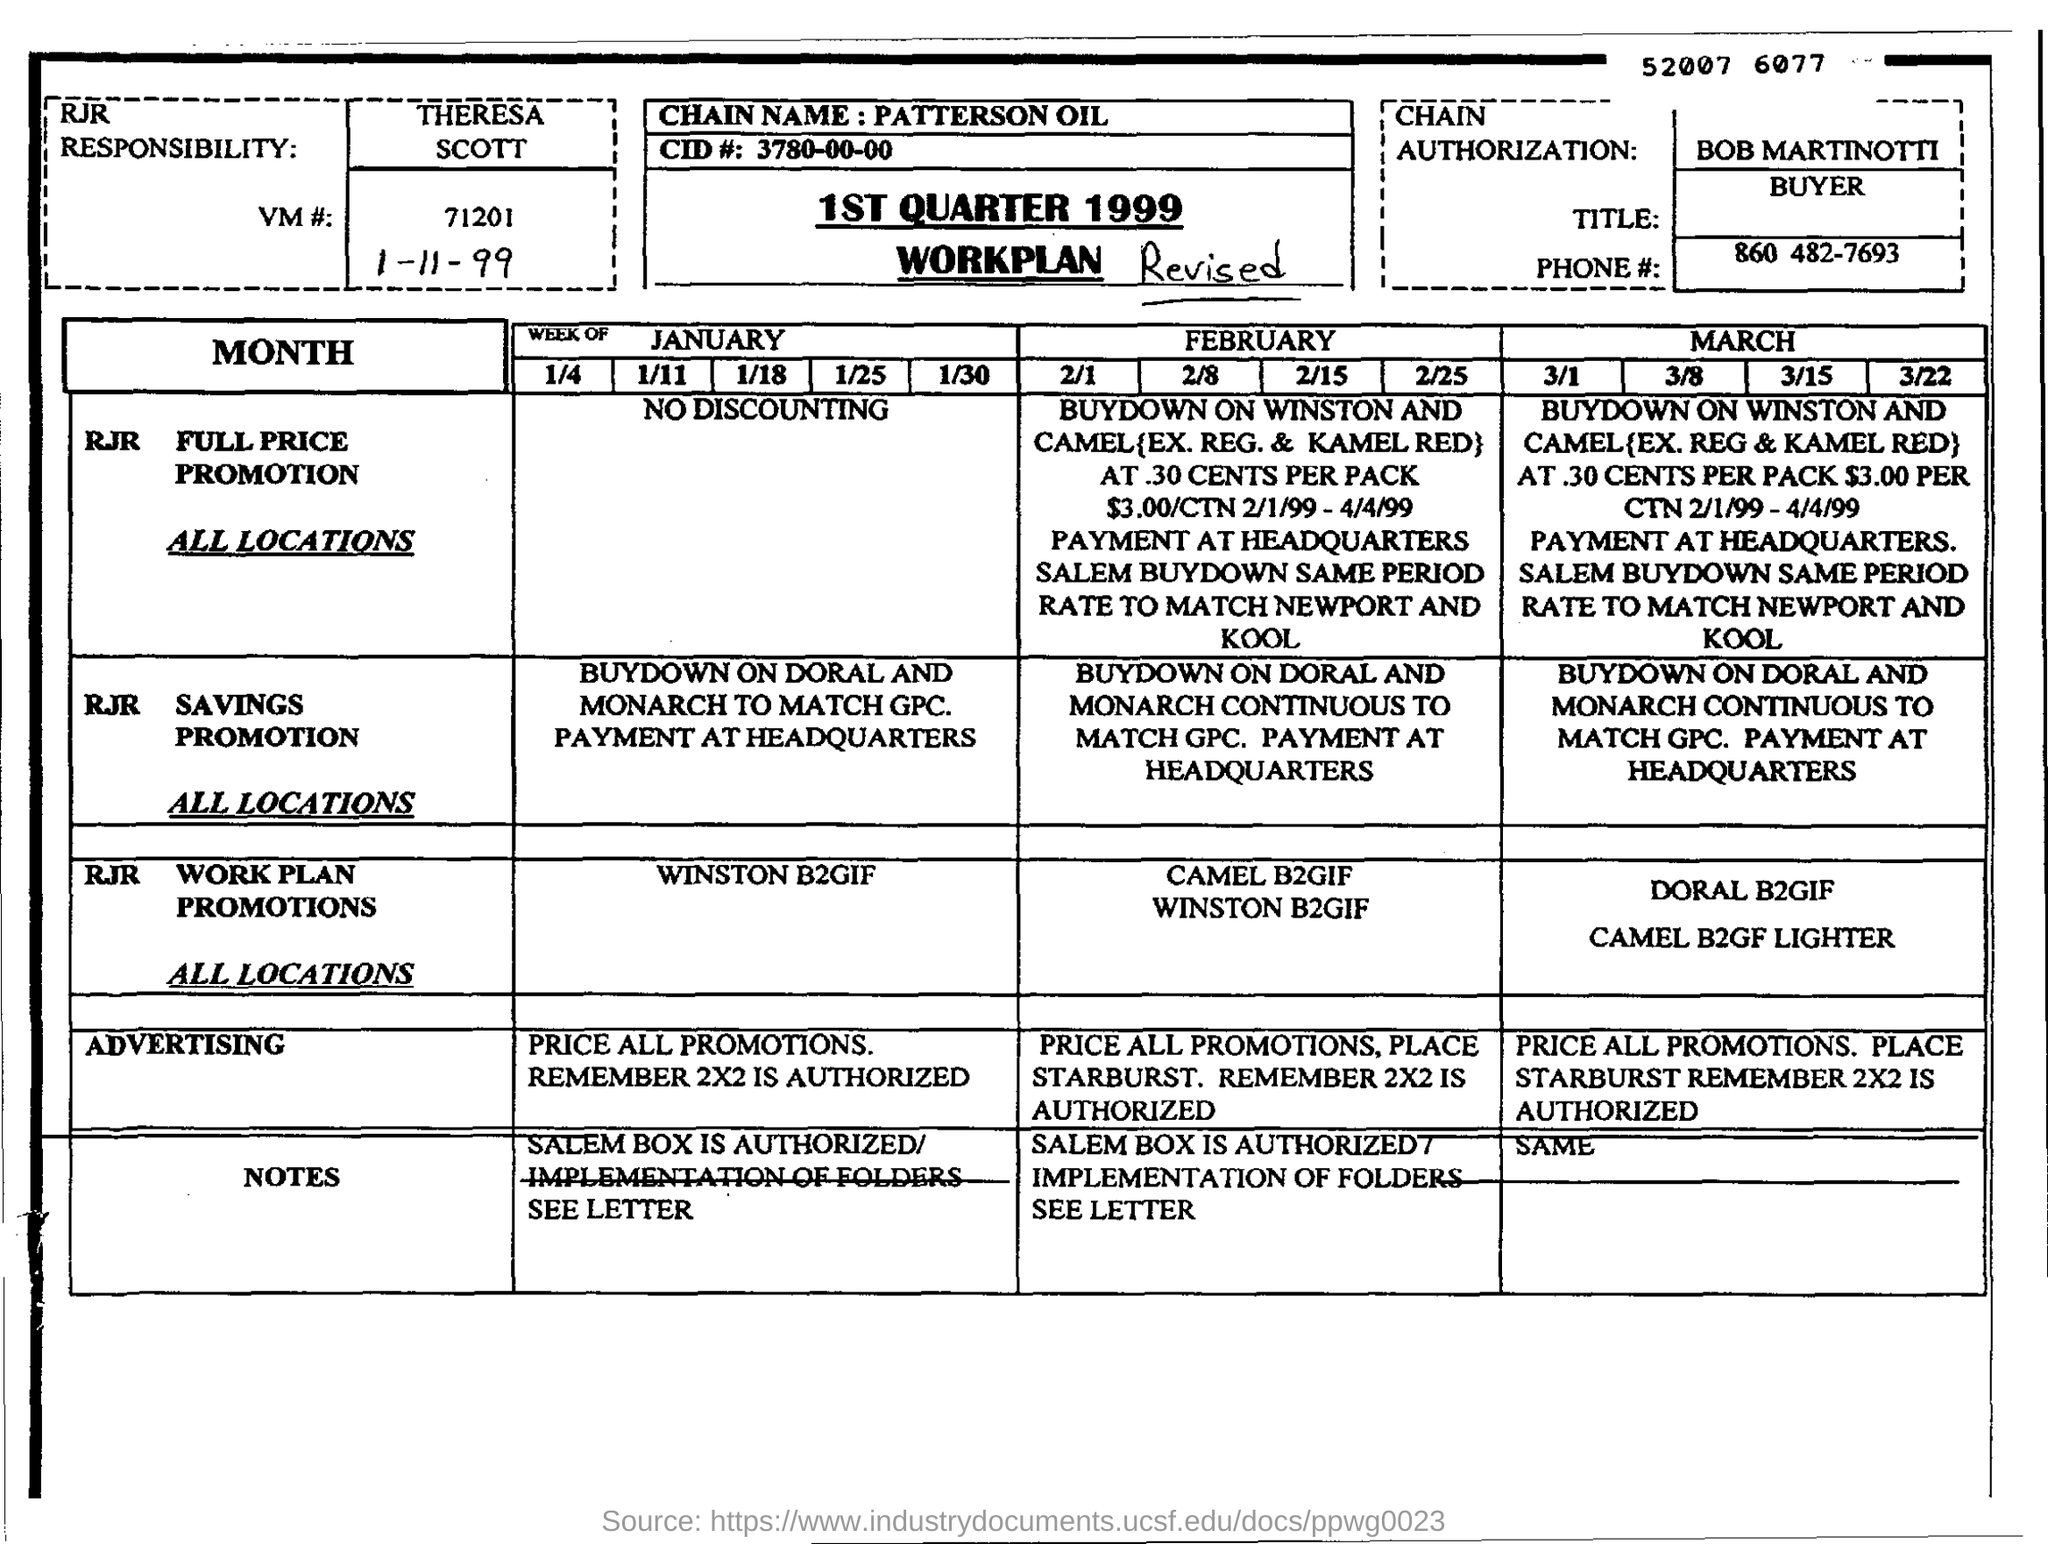What is date mentioned in this page?
Your response must be concise. 1-11-99. What is the Phone# in this document?
Ensure brevity in your answer.  860 482-7693. 